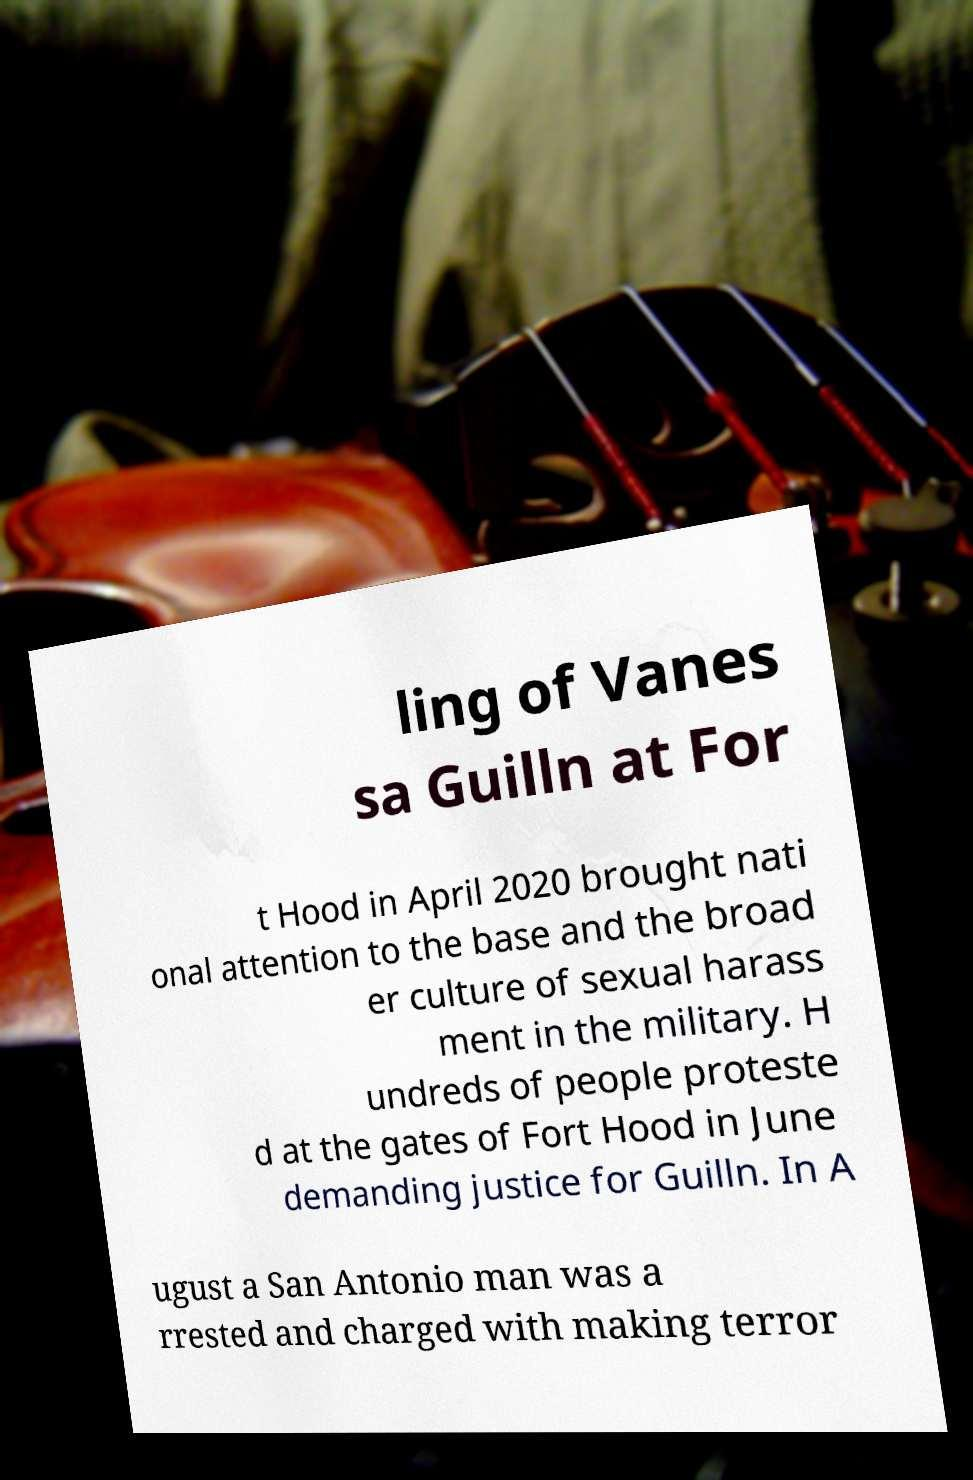There's text embedded in this image that I need extracted. Can you transcribe it verbatim? ling of Vanes sa Guilln at For t Hood in April 2020 brought nati onal attention to the base and the broad er culture of sexual harass ment in the military. H undreds of people proteste d at the gates of Fort Hood in June demanding justice for Guilln. In A ugust a San Antonio man was a rrested and charged with making terror 